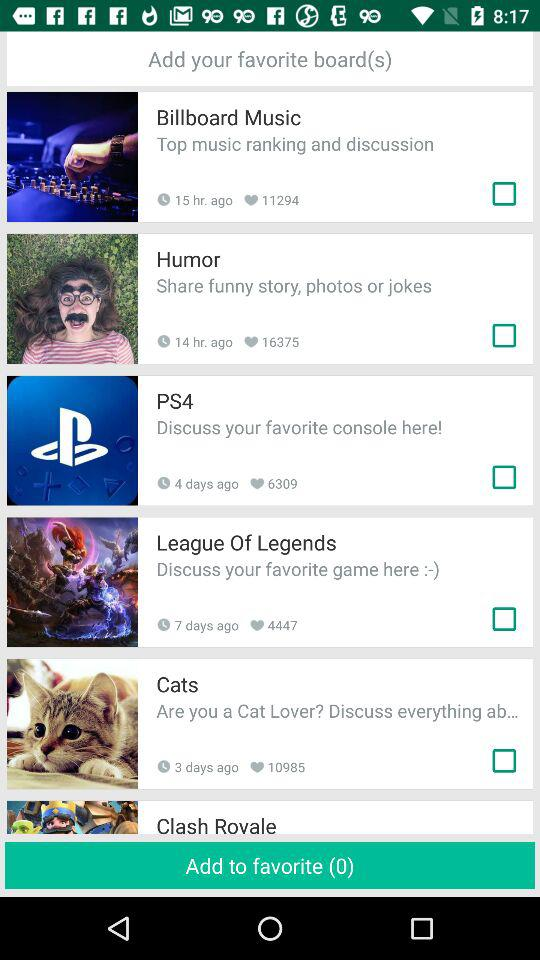When was "League Of Legends" posted? "League Of Legends" was posted 7 days ago. 